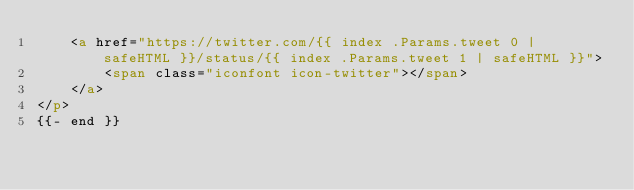<code> <loc_0><loc_0><loc_500><loc_500><_HTML_>    <a href="https://twitter.com/{{ index .Params.tweet 0 | safeHTML }}/status/{{ index .Params.tweet 1 | safeHTML }}">
        <span class="iconfont icon-twitter"></span>
    </a>
</p>
{{- end }}
</code> 